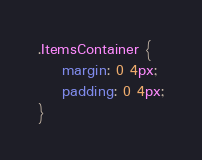<code> <loc_0><loc_0><loc_500><loc_500><_CSS_>.ItemsContainer {
	margin: 0 4px;
	padding: 0 4px;
}</code> 